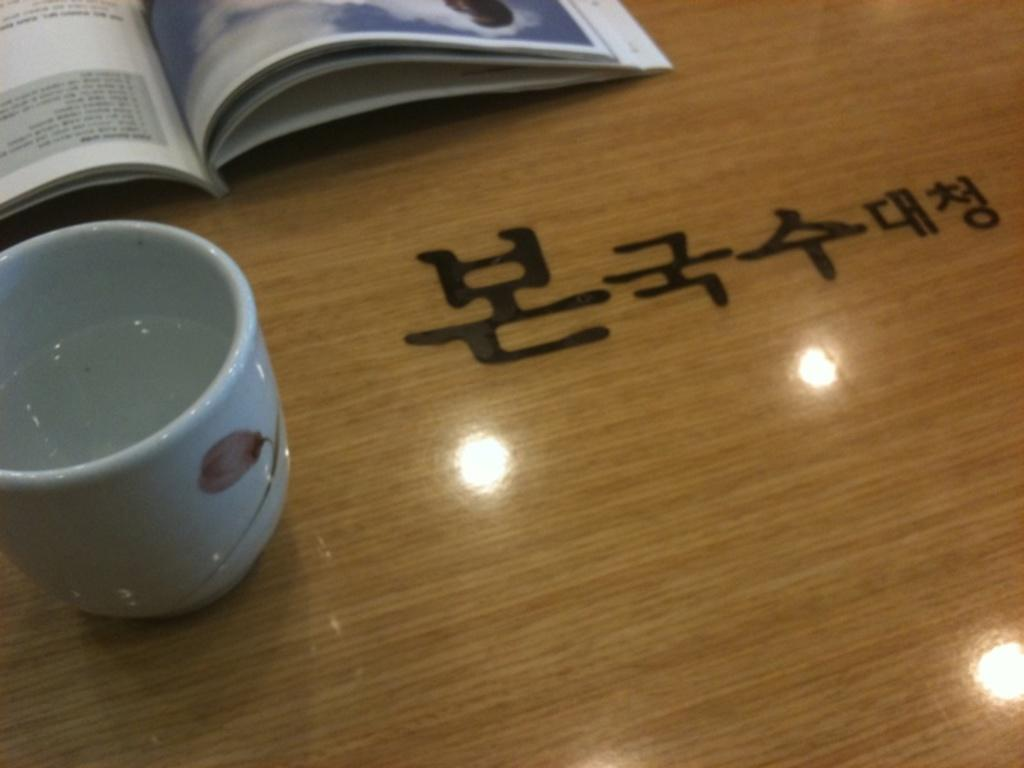What object is located on the left side of the image? There is a cup on the left side of the image. What is the color of the book that is visible in the image? The book is brown in color. What is the book resting on in the image? The book is on the table in the image. What can be seen on the table besides the book? There is text visible on the table. Can you tell me how many monkeys are sitting on the cup in the image? There are no monkeys present in the image; it only features a cup and a book on a table. What type of yarn is being used to create the text on the table? There is no yarn visible in the image; the text appears to be printed or written. 